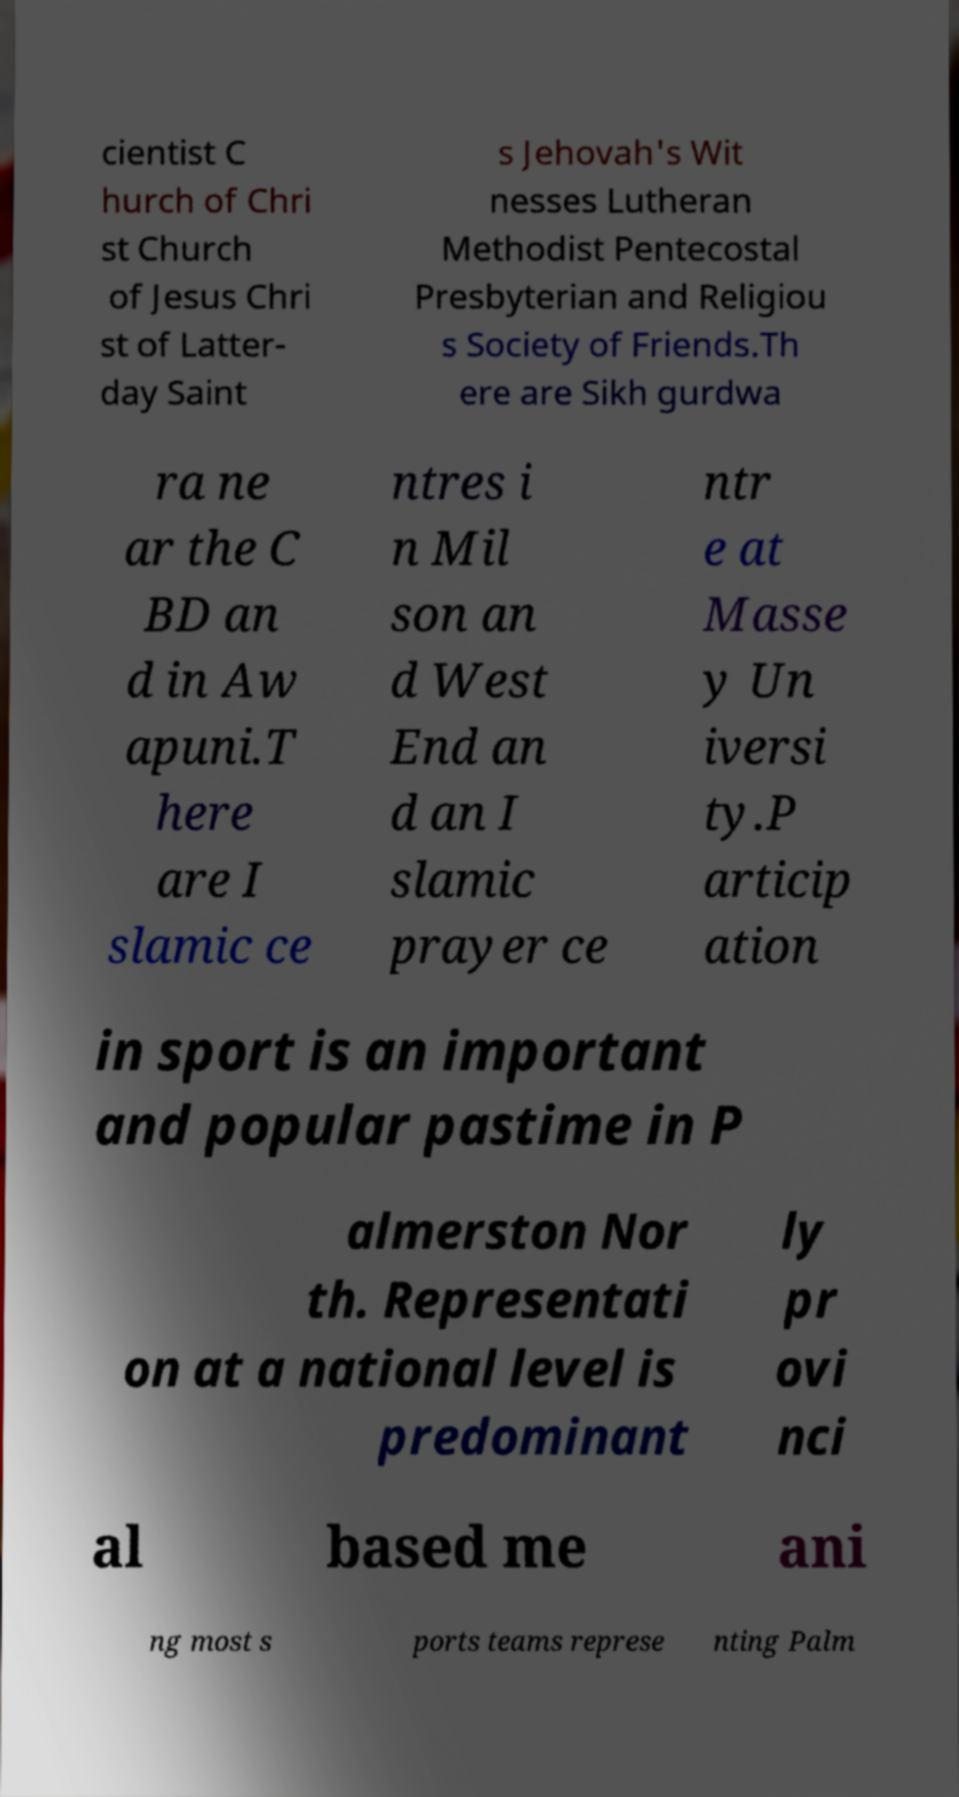Please read and relay the text visible in this image. What does it say? cientist C hurch of Chri st Church of Jesus Chri st of Latter- day Saint s Jehovah's Wit nesses Lutheran Methodist Pentecostal Presbyterian and Religiou s Society of Friends.Th ere are Sikh gurdwa ra ne ar the C BD an d in Aw apuni.T here are I slamic ce ntres i n Mil son an d West End an d an I slamic prayer ce ntr e at Masse y Un iversi ty.P articip ation in sport is an important and popular pastime in P almerston Nor th. Representati on at a national level is predominant ly pr ovi nci al based me ani ng most s ports teams represe nting Palm 